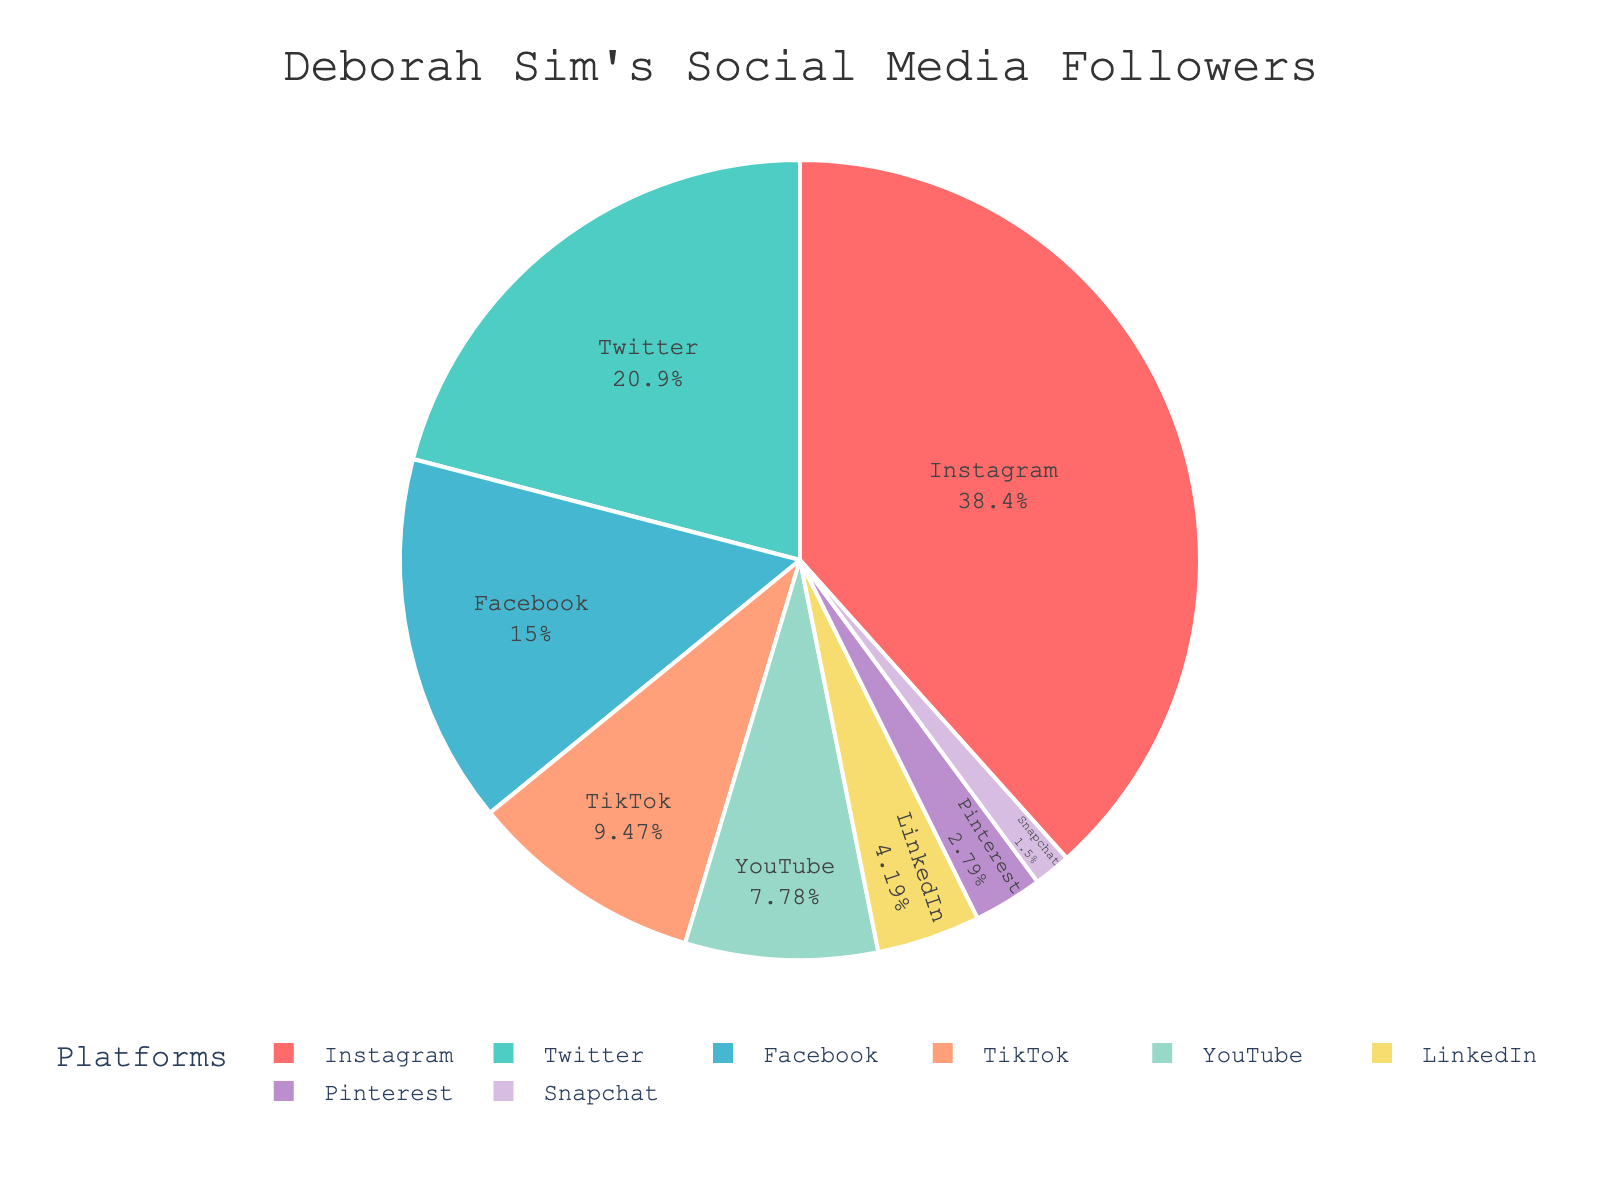How many followers does Deborah Sim have on YouTube and TikTok combined? To find the total number of followers on YouTube and TikTok, we need to sum the followers from both platforms: 78,000 (YouTube) + 95,000 (TikTok) = 173,000.
Answer: 173,000 Which platform has the highest number of followers? By examining the pie chart, we identify that Instagram has the largest segment, indicating it has the highest number of followers.
Answer: Instagram What is the percentage of total followers on Instagram? From the pie chart, we see that the Instagram segment occupies the largest portion. To find the exact percentage, we would look at the label inside the Instagram segment.
Answer: 41.2% Between Twitter and Facebook, which platform has more followers, and by how much? Comparing Twitter (210,000 followers) and Facebook (150,000 followers), we subtract Facebook's followers from Twitter's: 210,000 - 150,000 = 60,000. Twitter has more followers by 60,000.
Answer: Twitter, 60,000 What is the total number of followers across all platforms? Summing the followers from all platforms: 385,000 (Instagram) + 210,000 (Twitter) + 150,000 (Facebook) + 95,000 (TikTok) + 78,000 (YouTube) + 42,000 (LinkedIn) + 28,000 (Pinterest) + 15,000 (Snapchat) = 1,003,000.
Answer: 1,003,000 Which platform has the smallest number of followers and what is that number? The smallest segment in the pie chart represents the platform with the fewest followers. This is Snapchat with 15,000 followers.
Answer: Snapchat, 15,000 What fraction of the followers are on LinkedIn compared to all platforms combined? LinkedIn has 42,000 followers. To find the fraction of these followers compared to the total followers (1,003,000), we compute 42,000 / 1,003,000 ≈ 0.0419.
Answer: 0.0419 How many more followers does Instagram have than the average number of followers per platform? First, calculate the average number of followers: Total followers (1,003,000) / Number of platforms (8) = 125,375. Then, subtract this from Instagram’s followers: 385,000 - 125,375 = 259,625.
Answer: 259,625 What color represents the TikTok segment in the pie chart? By visually examining the pie chart, we observe the color associated with the TikTok segment.
Answer: Light blue What is the sum of followers on platforms having fewer than 100,000 followers? Summing the followers of platforms with fewer than 100,000 followers: YouTube (78,000) + LinkedIn (42,000) + Pinterest (28,000) + Snapchat (15,000) = 163,000.
Answer: 163,000 